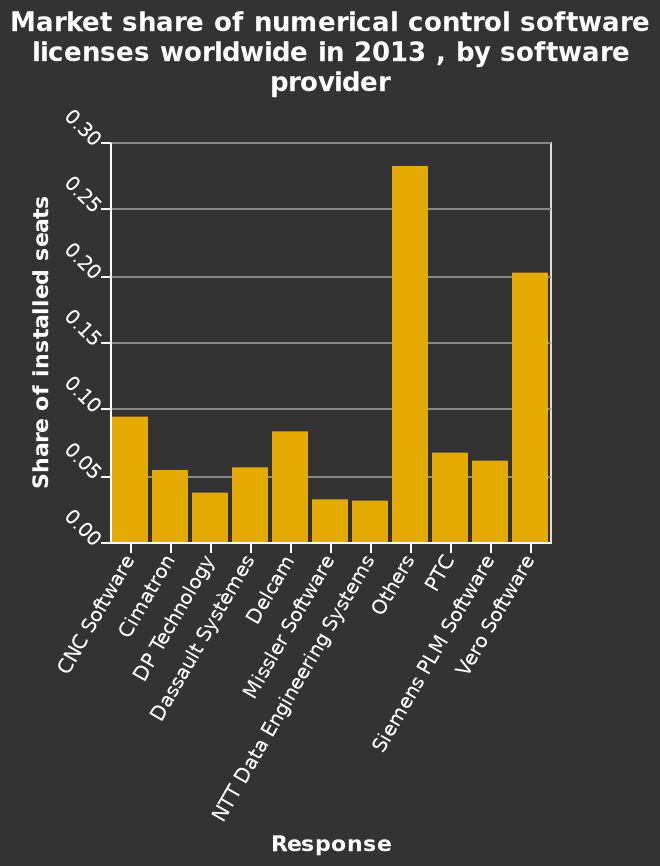<image>
How would you describe the competition among software providers? The competition among software providers is evenly distributed, with no one provider dominating. Is there a clear leader in the software provider industry?  No, there is no clear leader in the software provider industry. 